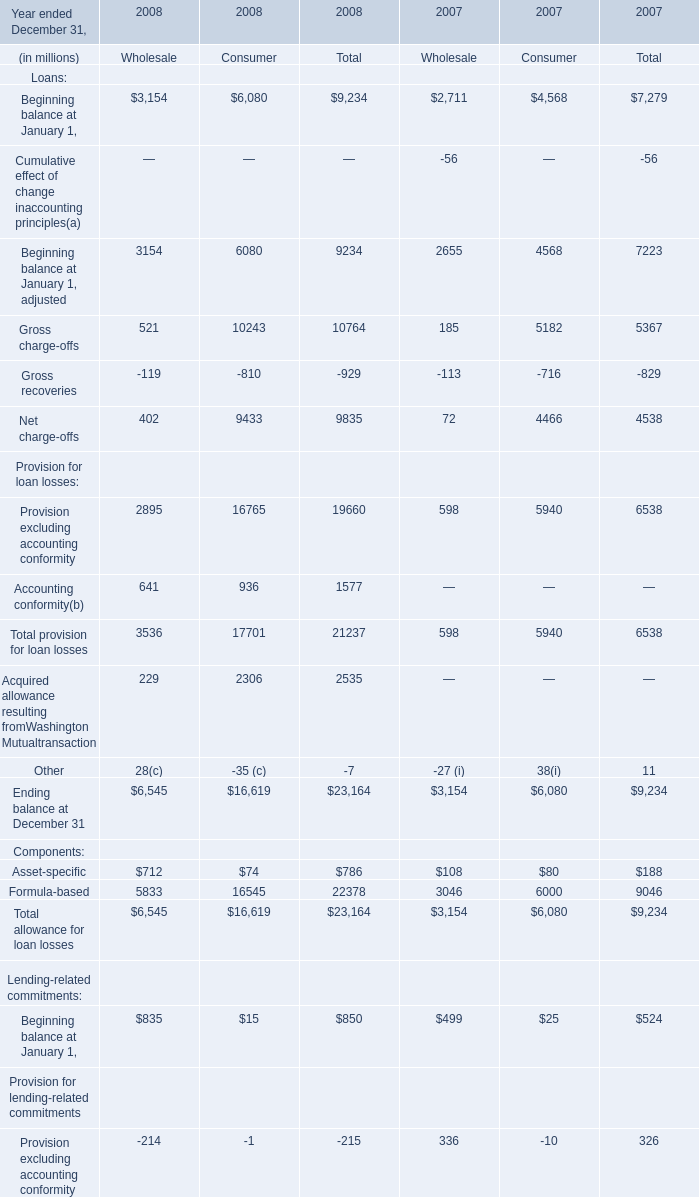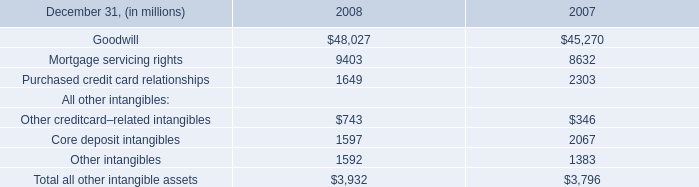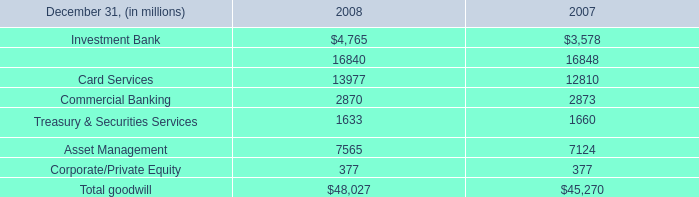What's the average of the Other creditcard–related intangibles for All other intangibles in the years where Treasury & Securities Services is positive? (in million) 
Computations: ((743 + 346) / 2)
Answer: 544.5. 